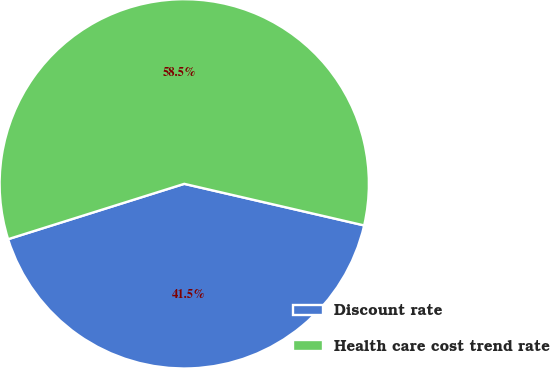Convert chart to OTSL. <chart><loc_0><loc_0><loc_500><loc_500><pie_chart><fcel>Discount rate<fcel>Health care cost trend rate<nl><fcel>41.54%<fcel>58.46%<nl></chart> 